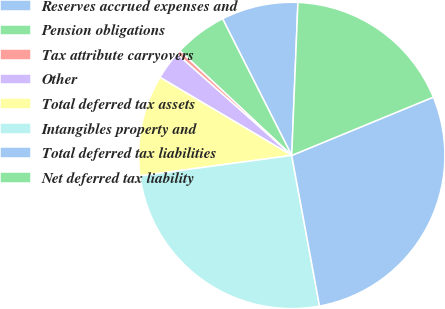Convert chart. <chart><loc_0><loc_0><loc_500><loc_500><pie_chart><fcel>Reserves accrued expenses and<fcel>Pension obligations<fcel>Tax attribute carryovers<fcel>Other<fcel>Total deferred tax assets<fcel>Intangibles property and<fcel>Total deferred tax liabilities<fcel>Net deferred tax liability<nl><fcel>8.1%<fcel>5.56%<fcel>0.46%<fcel>3.01%<fcel>10.65%<fcel>25.77%<fcel>28.31%<fcel>18.14%<nl></chart> 